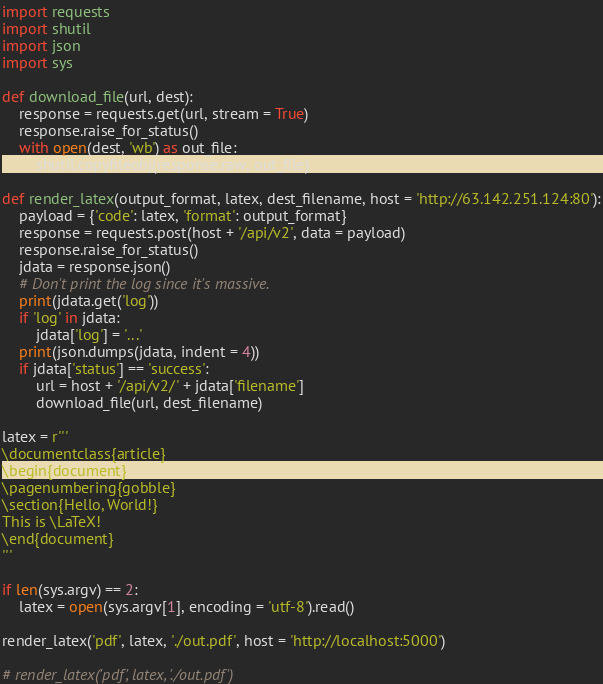<code> <loc_0><loc_0><loc_500><loc_500><_Python_>import requests
import shutil
import json
import sys

def download_file(url, dest):
	response = requests.get(url, stream = True)
	response.raise_for_status()
	with open(dest, 'wb') as out_file:
		shutil.copyfileobj(response.raw, out_file)

def render_latex(output_format, latex, dest_filename, host = 'http://63.142.251.124:80'):
	payload = {'code': latex, 'format': output_format}
	response = requests.post(host + '/api/v2', data = payload)
	response.raise_for_status()
	jdata = response.json()
	# Don't print the log since it's massive.
	print(jdata.get('log'))
	if 'log' in jdata:
		jdata['log'] = '...'
	print(json.dumps(jdata, indent = 4))
	if jdata['status'] == 'success':
		url = host + '/api/v2/' + jdata['filename']
		download_file(url, dest_filename)

latex = r'''
\documentclass{article}
\begin{document}
\pagenumbering{gobble}
\section{Hello, World!}
This is \LaTeX!
\end{document}
'''

if len(sys.argv) == 2:
	latex = open(sys.argv[1], encoding = 'utf-8').read()

render_latex('pdf', latex, './out.pdf', host = 'http://localhost:5000')

# render_latex('pdf', latex, './out.pdf')
</code> 